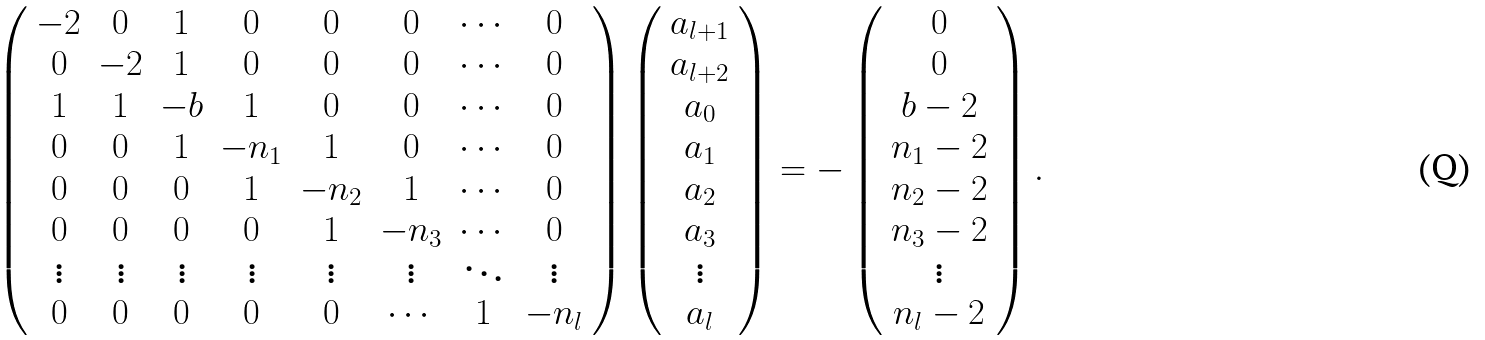<formula> <loc_0><loc_0><loc_500><loc_500>\left ( \begin{array} { c c c c c c c c } - 2 & 0 & 1 & 0 & 0 & 0 & \cdots & 0 \\ 0 & - 2 & 1 & 0 & 0 & 0 & \cdots & 0 \\ 1 & 1 & - b & 1 & 0 & 0 & \cdots & 0 \\ 0 & 0 & 1 & - n _ { 1 } & 1 & 0 & \cdots & 0 \\ 0 & 0 & 0 & 1 & - n _ { 2 } & 1 & \cdots & 0 \\ 0 & 0 & 0 & 0 & 1 & - n _ { 3 } & \cdots & 0 \\ \vdots & \vdots & \vdots & \vdots & \vdots & \vdots & \ddots & \vdots \\ 0 & 0 & 0 & 0 & 0 & \cdots & 1 & - n _ { l } \\ \end{array} \right ) \left ( \begin{array} { c } a _ { l + 1 } \\ a _ { l + 2 } \\ a _ { 0 } \\ a _ { 1 } \\ a _ { 2 } \\ a _ { 3 } \\ \vdots \\ a _ { l } \\ \end{array} \right ) = - \left ( \begin{array} { c } 0 \\ 0 \\ b - 2 \\ n _ { 1 } - 2 \\ n _ { 2 } - 2 \\ n _ { 3 } - 2 \\ \vdots \\ n _ { l } - 2 \\ \end{array} \right ) .</formula> 